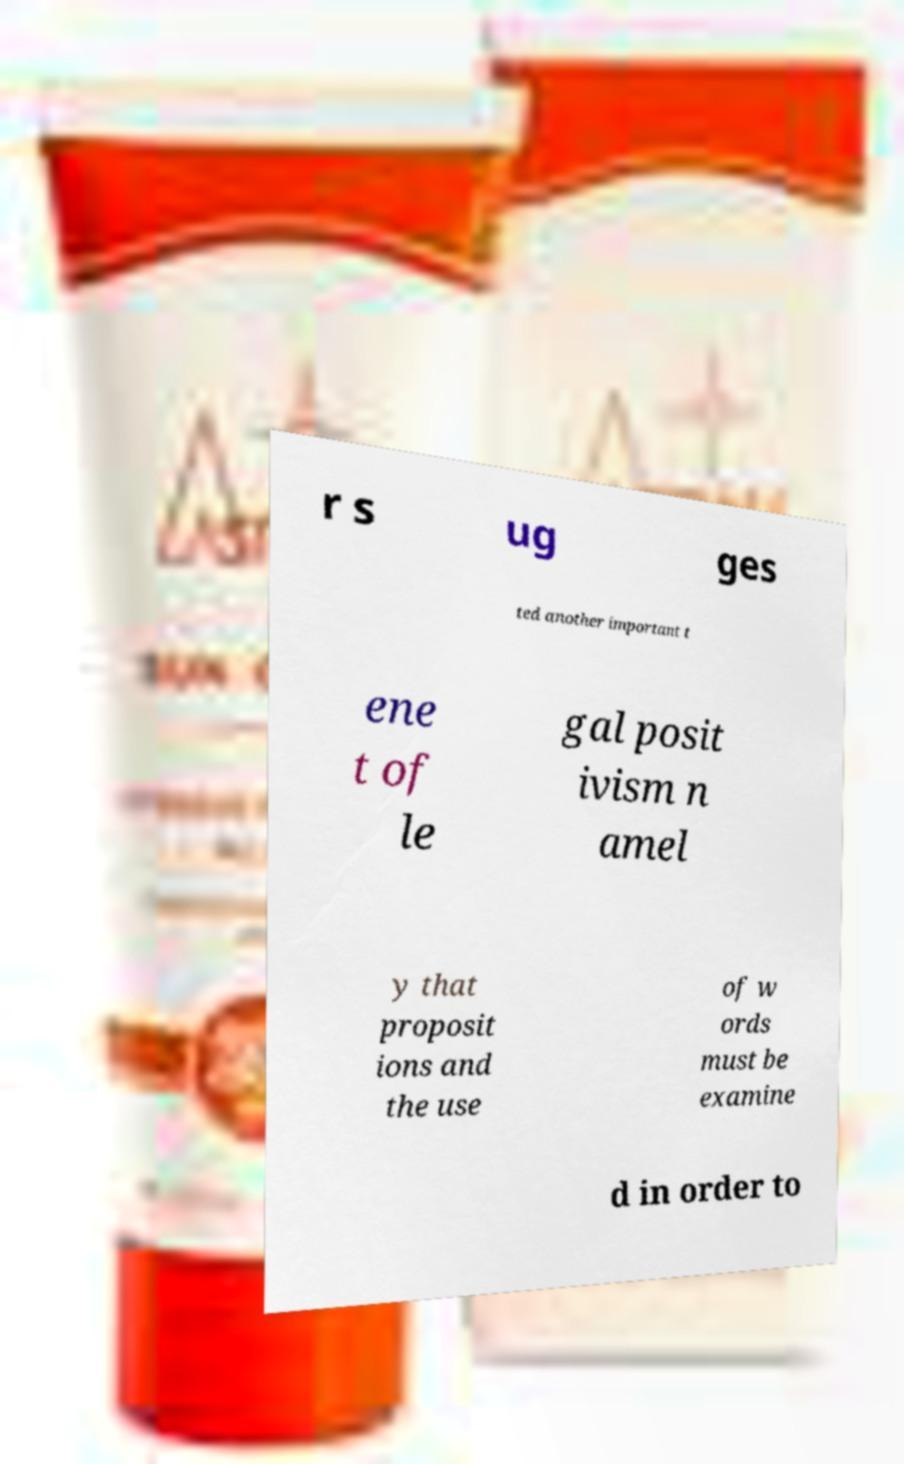There's text embedded in this image that I need extracted. Can you transcribe it verbatim? r s ug ges ted another important t ene t of le gal posit ivism n amel y that proposit ions and the use of w ords must be examine d in order to 